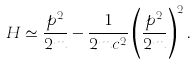<formula> <loc_0><loc_0><loc_500><loc_500>H \simeq \frac { p ^ { 2 } } { 2 m } - \frac { 1 } { 2 m c ^ { 2 } } \left ( \frac { p ^ { 2 } } { 2 m } \right ) ^ { 2 } .</formula> 